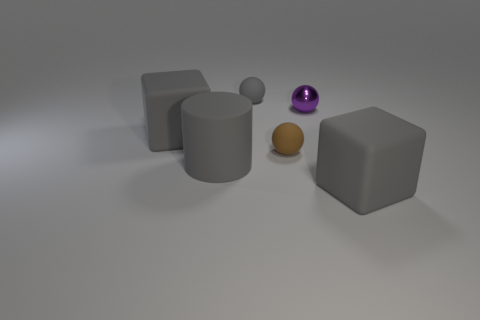There is a small brown thing that is made of the same material as the big cylinder; what shape is it?
Ensure brevity in your answer.  Sphere. How many matte things are on the right side of the tiny gray ball and in front of the brown rubber thing?
Make the answer very short. 1. Are there any gray matte cylinders left of the gray cylinder?
Your response must be concise. No. Is the shape of the gray matte object that is to the right of the purple shiny thing the same as the small object that is to the left of the tiny brown matte object?
Keep it short and to the point. No. How many objects are either big gray things or big matte cubes behind the large rubber cylinder?
Make the answer very short. 3. What number of other objects are the same shape as the metallic thing?
Make the answer very short. 2. Are the gray object behind the purple thing and the purple sphere made of the same material?
Keep it short and to the point. No. What number of things are matte objects or purple balls?
Offer a terse response. 6. There is a gray rubber thing that is the same shape as the small purple thing; what is its size?
Keep it short and to the point. Small. The gray matte cylinder is what size?
Make the answer very short. Large. 